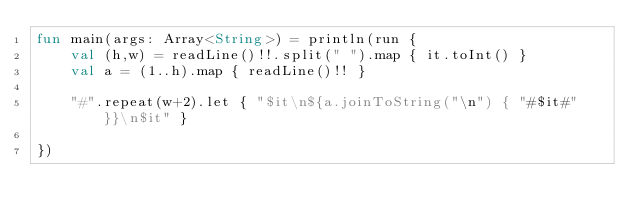Convert code to text. <code><loc_0><loc_0><loc_500><loc_500><_Kotlin_>fun main(args: Array<String>) = println(run {
    val (h,w) = readLine()!!.split(" ").map { it.toInt() }
    val a = (1..h).map { readLine()!! }

    "#".repeat(w+2).let { "$it\n${a.joinToString("\n") { "#$it#" }}\n$it" }

})
</code> 